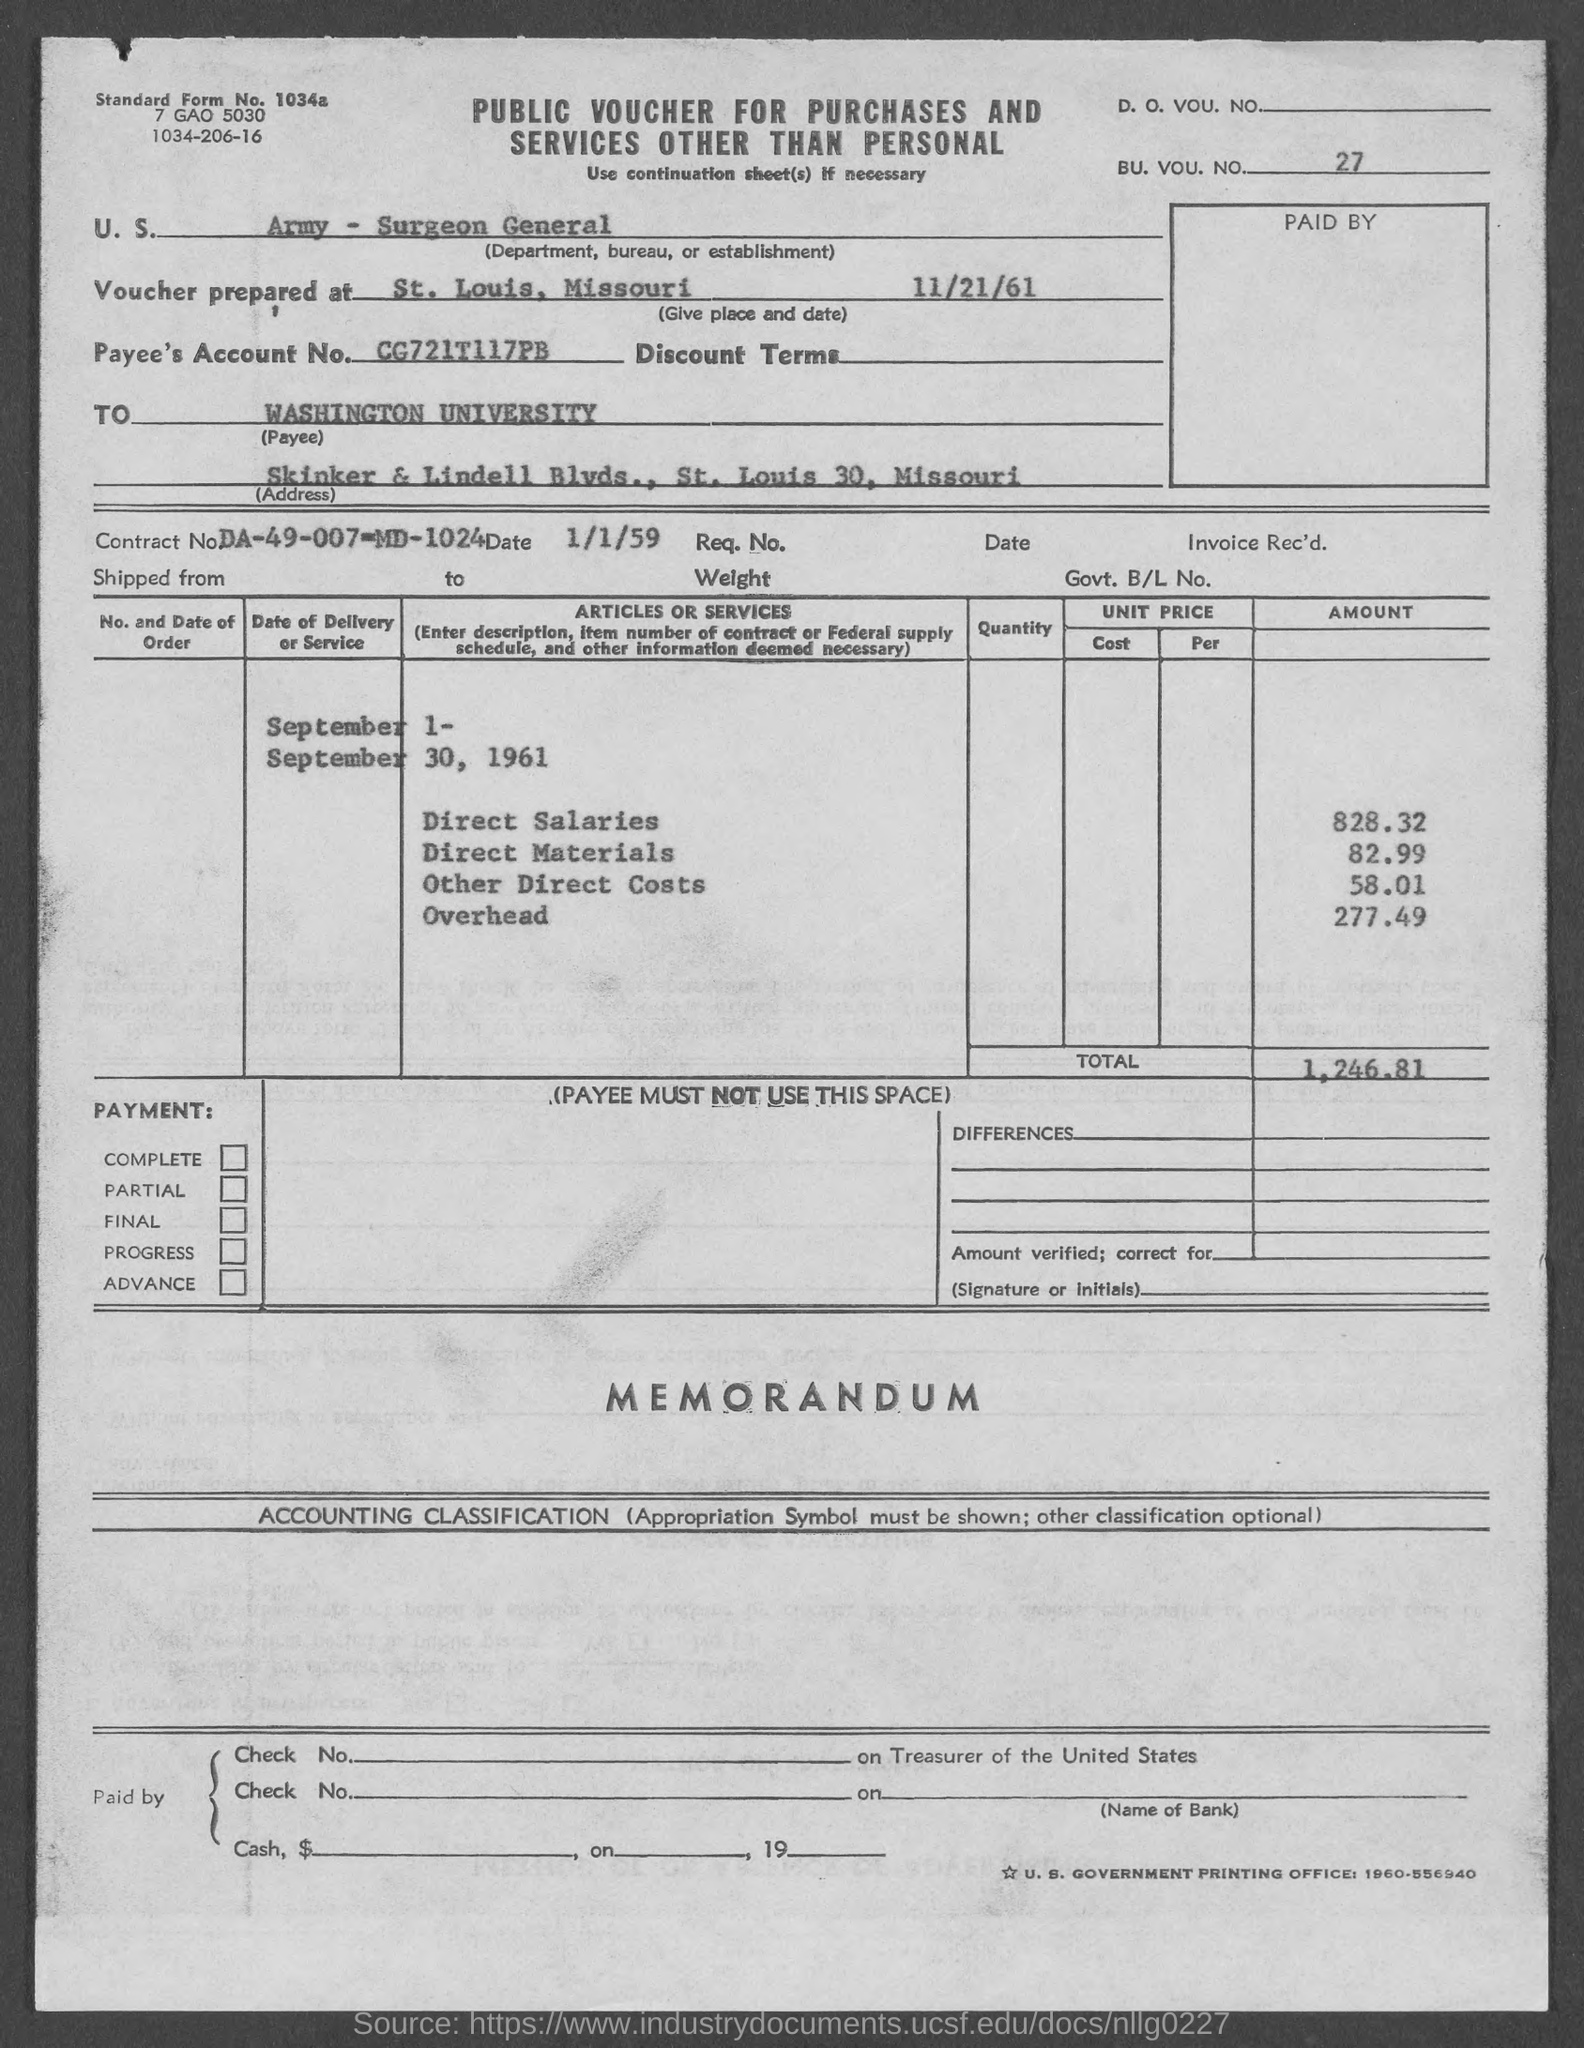Indicate a few pertinent items in this graphic. The amount of other direct costs is 58.01. The location of Washington University is in the state of Missouri. The payee's account number is CG721T117PB.. The total is 1,246.81 dollars. The overhead is 277.49. 